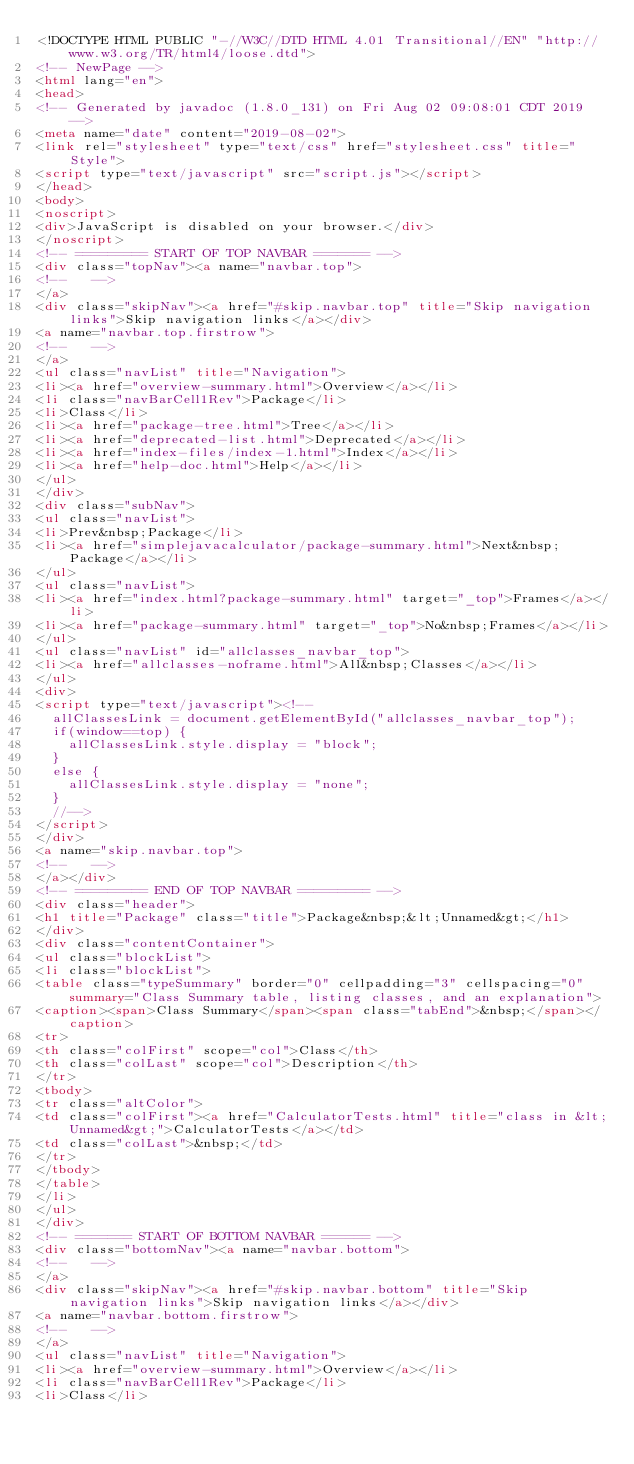<code> <loc_0><loc_0><loc_500><loc_500><_HTML_><!DOCTYPE HTML PUBLIC "-//W3C//DTD HTML 4.01 Transitional//EN" "http://www.w3.org/TR/html4/loose.dtd">
<!-- NewPage -->
<html lang="en">
<head>
<!-- Generated by javadoc (1.8.0_131) on Fri Aug 02 09:08:01 CDT 2019 -->
<meta name="date" content="2019-08-02">
<link rel="stylesheet" type="text/css" href="stylesheet.css" title="Style">
<script type="text/javascript" src="script.js"></script>
</head>
<body>
<noscript>
<div>JavaScript is disabled on your browser.</div>
</noscript>
<!-- ========= START OF TOP NAVBAR ======= -->
<div class="topNav"><a name="navbar.top">
<!--   -->
</a>
<div class="skipNav"><a href="#skip.navbar.top" title="Skip navigation links">Skip navigation links</a></div>
<a name="navbar.top.firstrow">
<!--   -->
</a>
<ul class="navList" title="Navigation">
<li><a href="overview-summary.html">Overview</a></li>
<li class="navBarCell1Rev">Package</li>
<li>Class</li>
<li><a href="package-tree.html">Tree</a></li>
<li><a href="deprecated-list.html">Deprecated</a></li>
<li><a href="index-files/index-1.html">Index</a></li>
<li><a href="help-doc.html">Help</a></li>
</ul>
</div>
<div class="subNav">
<ul class="navList">
<li>Prev&nbsp;Package</li>
<li><a href="simplejavacalculator/package-summary.html">Next&nbsp;Package</a></li>
</ul>
<ul class="navList">
<li><a href="index.html?package-summary.html" target="_top">Frames</a></li>
<li><a href="package-summary.html" target="_top">No&nbsp;Frames</a></li>
</ul>
<ul class="navList" id="allclasses_navbar_top">
<li><a href="allclasses-noframe.html">All&nbsp;Classes</a></li>
</ul>
<div>
<script type="text/javascript"><!--
  allClassesLink = document.getElementById("allclasses_navbar_top");
  if(window==top) {
    allClassesLink.style.display = "block";
  }
  else {
    allClassesLink.style.display = "none";
  }
  //-->
</script>
</div>
<a name="skip.navbar.top">
<!--   -->
</a></div>
<!-- ========= END OF TOP NAVBAR ========= -->
<div class="header">
<h1 title="Package" class="title">Package&nbsp;&lt;Unnamed&gt;</h1>
</div>
<div class="contentContainer">
<ul class="blockList">
<li class="blockList">
<table class="typeSummary" border="0" cellpadding="3" cellspacing="0" summary="Class Summary table, listing classes, and an explanation">
<caption><span>Class Summary</span><span class="tabEnd">&nbsp;</span></caption>
<tr>
<th class="colFirst" scope="col">Class</th>
<th class="colLast" scope="col">Description</th>
</tr>
<tbody>
<tr class="altColor">
<td class="colFirst"><a href="CalculatorTests.html" title="class in &lt;Unnamed&gt;">CalculatorTests</a></td>
<td class="colLast">&nbsp;</td>
</tr>
</tbody>
</table>
</li>
</ul>
</div>
<!-- ======= START OF BOTTOM NAVBAR ====== -->
<div class="bottomNav"><a name="navbar.bottom">
<!--   -->
</a>
<div class="skipNav"><a href="#skip.navbar.bottom" title="Skip navigation links">Skip navigation links</a></div>
<a name="navbar.bottom.firstrow">
<!--   -->
</a>
<ul class="navList" title="Navigation">
<li><a href="overview-summary.html">Overview</a></li>
<li class="navBarCell1Rev">Package</li>
<li>Class</li></code> 